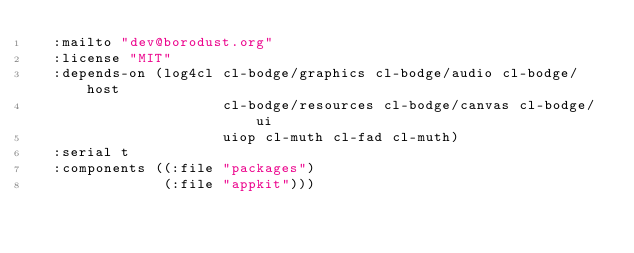<code> <loc_0><loc_0><loc_500><loc_500><_Lisp_>  :mailto "dev@borodust.org"
  :license "MIT"
  :depends-on (log4cl cl-bodge/graphics cl-bodge/audio cl-bodge/host
                      cl-bodge/resources cl-bodge/canvas cl-bodge/ui
                      uiop cl-muth cl-fad cl-muth)
  :serial t
  :components ((:file "packages")
               (:file "appkit")))
</code> 